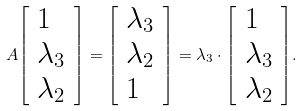<formula> <loc_0><loc_0><loc_500><loc_500>A { \left [ \begin{array} { l } { 1 } \\ { \lambda _ { 3 } } \\ { \lambda _ { 2 } } \end{array} \right ] } = { \left [ \begin{array} { l } { \lambda _ { 3 } } \\ { \lambda _ { 2 } } \\ { 1 } \end{array} \right ] } = \lambda _ { 3 } \cdot { \left [ \begin{array} { l } { 1 } \\ { \lambda _ { 3 } } \\ { \lambda _ { 2 } } \end{array} \right ] } .</formula> 